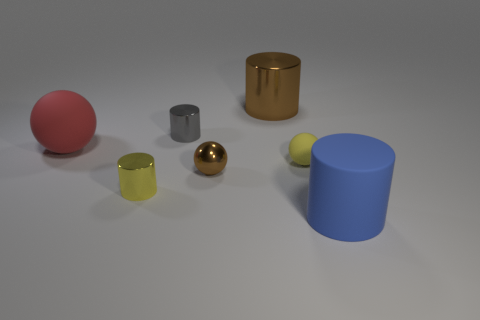Is the number of small blue things greater than the number of tiny yellow cylinders?
Your answer should be very brief. No. What is the material of the blue object that is the same shape as the yellow shiny object?
Your answer should be very brief. Rubber. Does the tiny gray cylinder have the same material as the red object?
Your answer should be compact. No. Are there more gray metal cylinders that are right of the small rubber ball than large matte things?
Provide a short and direct response. No. The large cylinder that is in front of the brown object that is in front of the rubber ball to the left of the yellow metallic cylinder is made of what material?
Provide a succinct answer. Rubber. What number of things are cyan things or objects that are in front of the small yellow metal cylinder?
Provide a short and direct response. 1. Do the rubber sphere to the right of the big ball and the large sphere have the same color?
Your response must be concise. No. Is the number of large blue cylinders left of the big blue rubber cylinder greater than the number of large matte things that are to the left of the gray cylinder?
Provide a succinct answer. No. Is there any other thing that is the same color as the large matte cylinder?
Offer a very short reply. No. What number of things are either large red rubber things or small yellow metallic cylinders?
Provide a short and direct response. 2. 